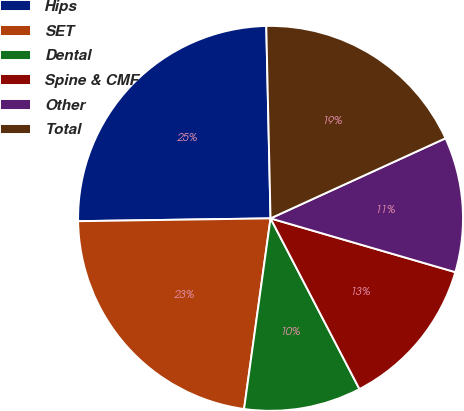Convert chart. <chart><loc_0><loc_0><loc_500><loc_500><pie_chart><fcel>Hips<fcel>SET<fcel>Dental<fcel>Spine & CMF<fcel>Other<fcel>Total<nl><fcel>24.88%<fcel>22.57%<fcel>9.84%<fcel>12.85%<fcel>11.34%<fcel>18.52%<nl></chart> 